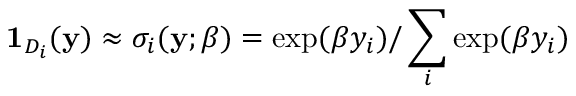<formula> <loc_0><loc_0><loc_500><loc_500>1 _ { D _ { i } } ( y ) \approx \sigma _ { i } ( y ; \beta ) = \exp ( \beta y _ { i } ) / \sum _ { i } \exp ( \beta y _ { i } )</formula> 